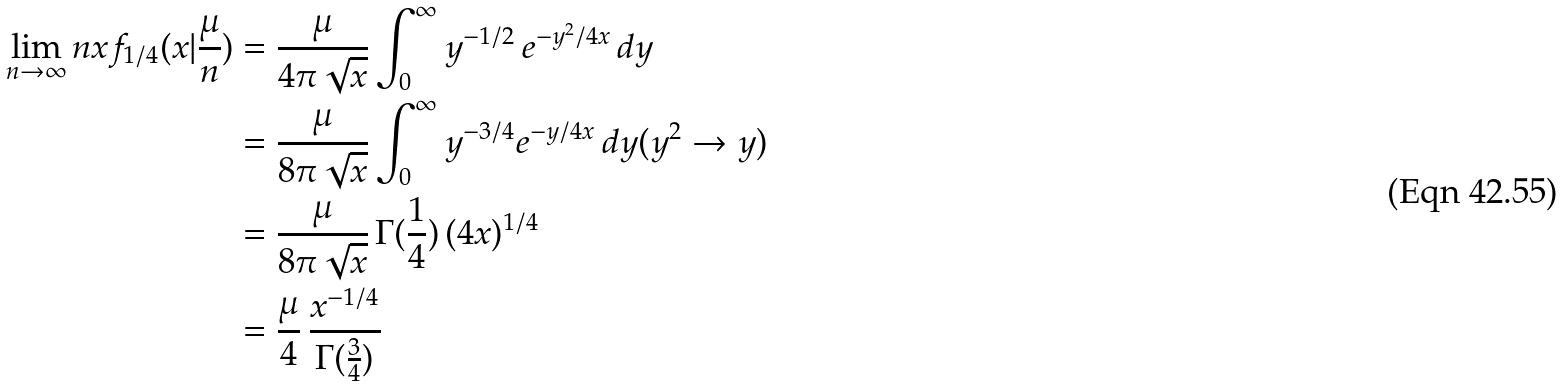Convert formula to latex. <formula><loc_0><loc_0><loc_500><loc_500>\lim _ { n \to \infty } n x f _ { 1 / 4 } ( x | \frac { \mu } { n } ) & = \frac { \mu } { 4 \pi \sqrt { x } } \int _ { 0 } ^ { \infty } y ^ { - 1 / 2 } \, e ^ { - y ^ { 2 } / 4 x } \, d y \\ & = \frac { \mu } { 8 \pi \sqrt { x } } \int _ { 0 } ^ { \infty } y ^ { - 3 / 4 } e ^ { - y / 4 x } \, d y ( y ^ { 2 } \to y ) \\ & = \frac { \mu } { 8 \pi \sqrt { x } } \, \Gamma ( \frac { 1 } { 4 } ) \, ( 4 x ) ^ { 1 / 4 } \\ & = \frac { \mu } { 4 } \, \frac { x ^ { - 1 / 4 } } { \Gamma ( \frac { 3 } { 4 } ) }</formula> 